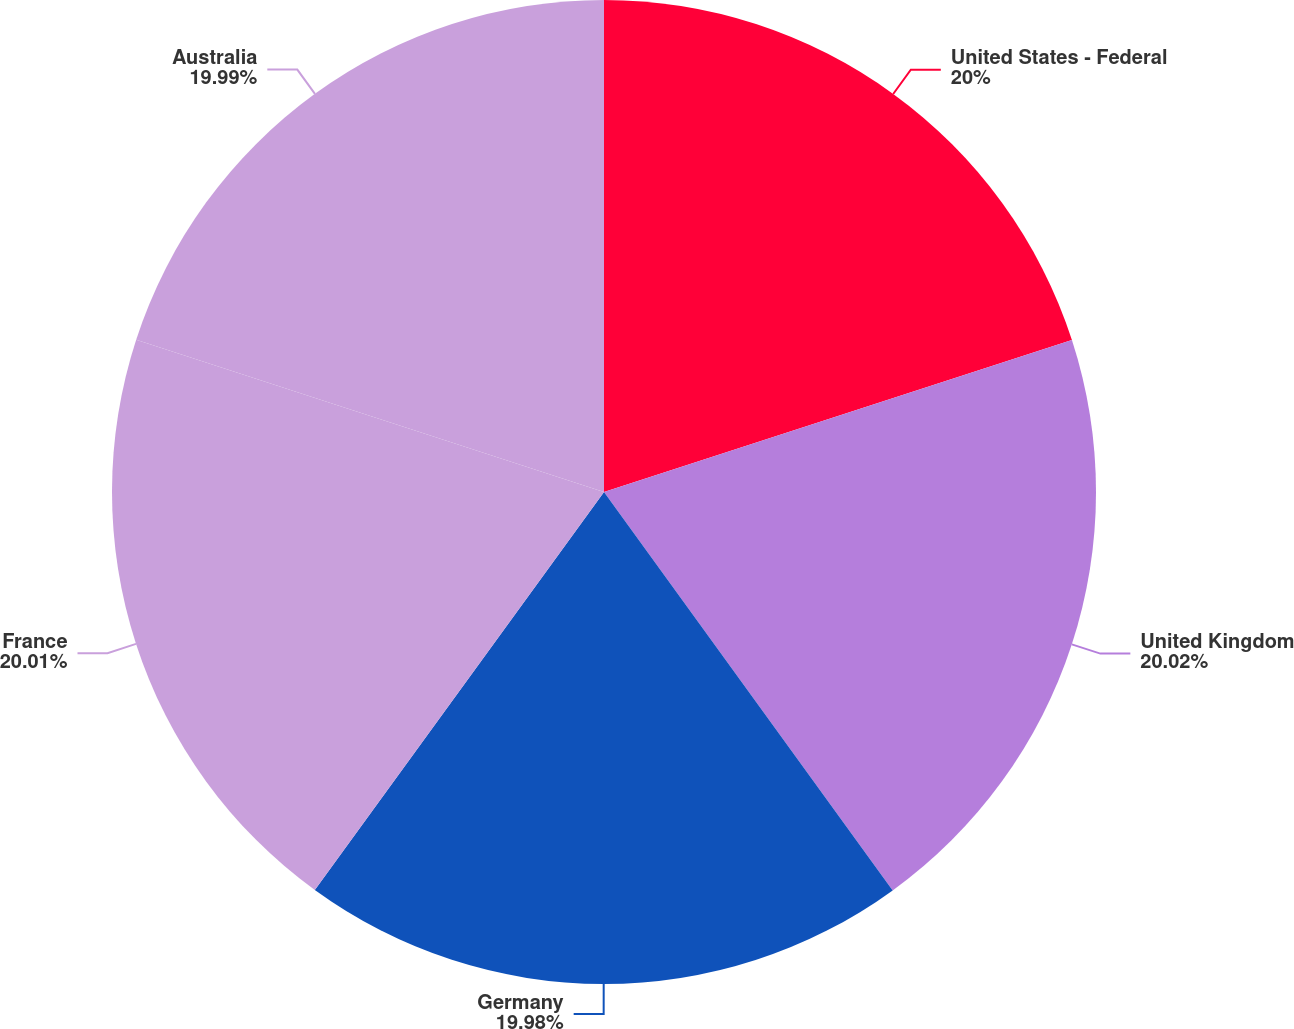<chart> <loc_0><loc_0><loc_500><loc_500><pie_chart><fcel>United States - Federal<fcel>United Kingdom<fcel>Germany<fcel>France<fcel>Australia<nl><fcel>20.0%<fcel>20.02%<fcel>19.98%<fcel>20.01%<fcel>19.99%<nl></chart> 